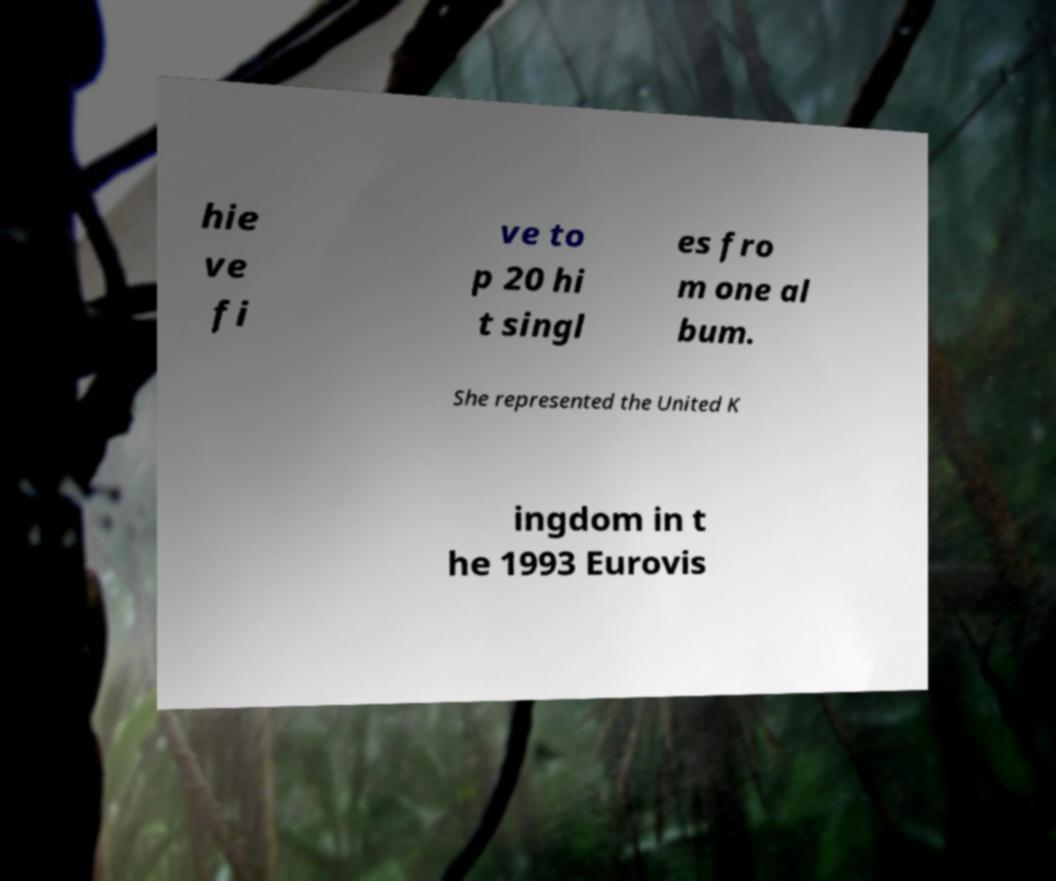Can you read and provide the text displayed in the image?This photo seems to have some interesting text. Can you extract and type it out for me? hie ve fi ve to p 20 hi t singl es fro m one al bum. She represented the United K ingdom in t he 1993 Eurovis 